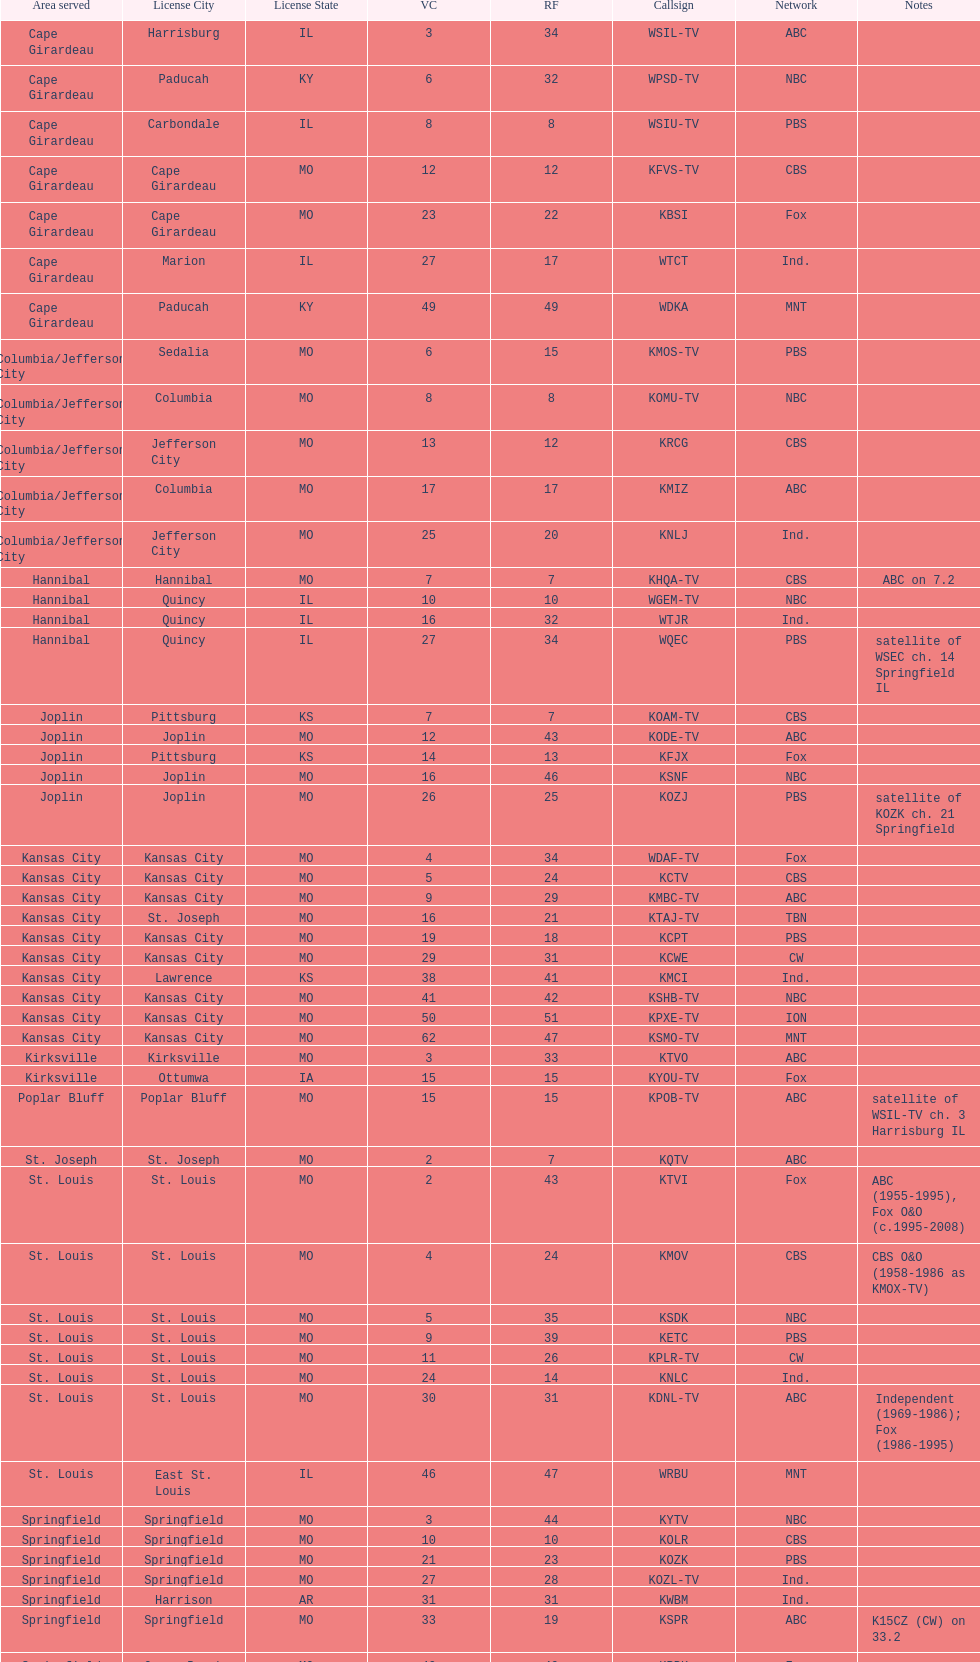Which station is licensed in the same city as koam-tv? KFJX. 